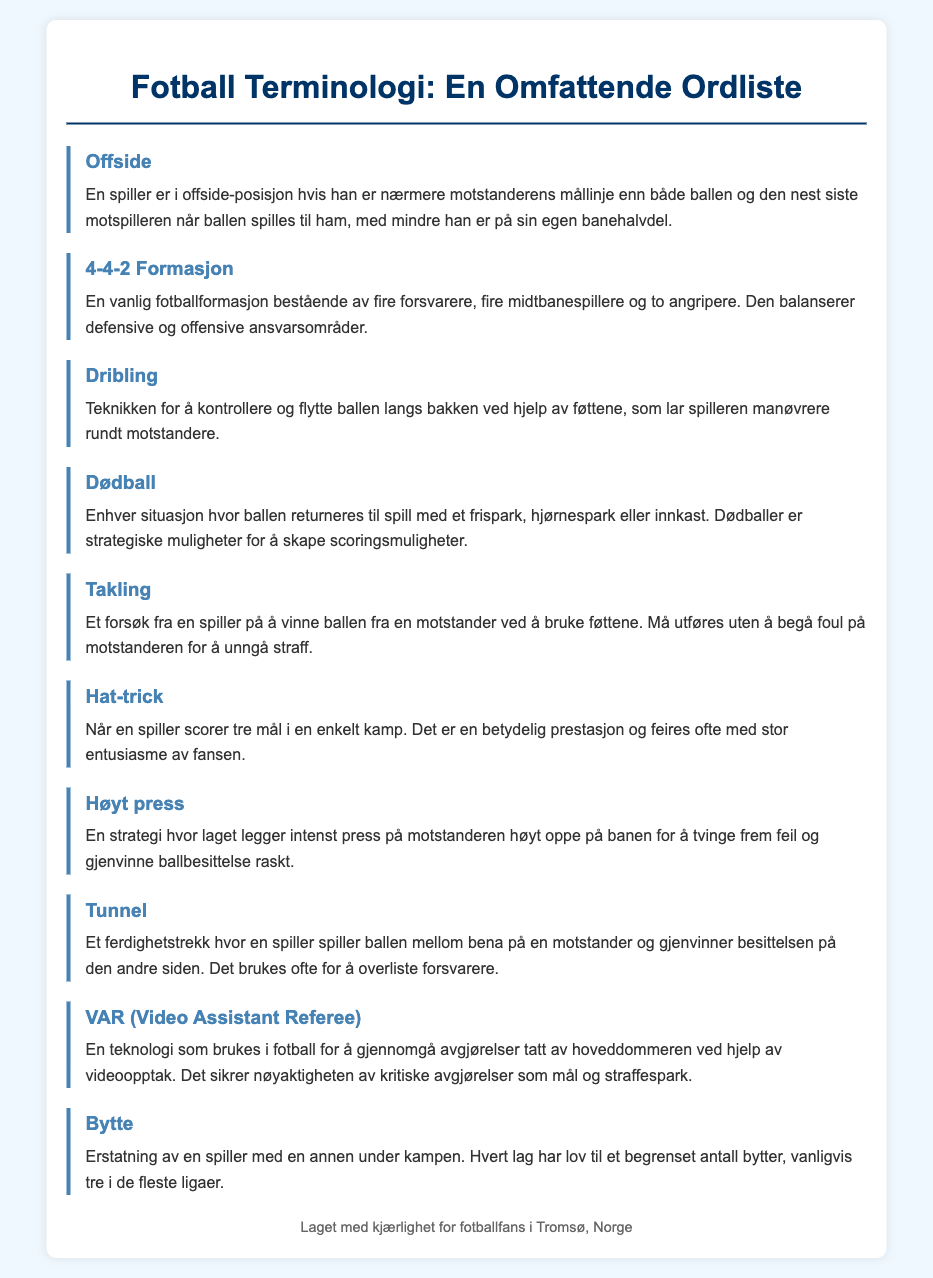What is the definition of offside? Offside is defined in the glossary as a position where a player is closer to the opponent's goal line than both the ball and the second last opponent when the ball is played to him, unless he is in his own half.
Answer: En spiller er i offside-posisjon hvis han er nærmere motstanderens mållinje enn både ballen og den nest siste motspilleren når ballen spilles til ham, med mindre han er på sin egen banehalvdel What does 4-4-2 formation consist of? The 4-4-2 formation consists of four defenders, four midfielders, and two forwards, balancing defensive and offensive responsibilities.
Answer: Fire forsvarere, fire midtbanespillere og to angripere What is a hat-trick? A hat-trick is when a player scores three goals in a single match, which is a significant achievement celebrated by fans.
Answer: Når en spiller scorer tre mål i en enkelt kamp What is the purpose of dead balls? Dead balls provide strategic opportunities to create scoring chances through free kicks, corner kicks, or throw-ins.
Answer: Strategiske muligheter for å skape scoringsmuligheter How many substitutions are typically allowed in most leagues? Most leagues typically allow three substitutes during a match.
Answer: Vanligvis tre What strategy does "high pressing" involve? High pressing involves putting intense pressure on the opponent high up the pitch to force errors and quickly regain possession.
Answer: Legge intenst press på motstanderen høyt oppe på banen What does VAR stand for? VAR stands for Video Assistant Referee, a technology used to review decisions made by the main referee.
Answer: Video Assistant Referee What skill does the term "tunnel" refer to? Tunnel refers to the skill of playing the ball between an opponent's legs and regaining possession on the other side.
Answer: Spille ballen mellom bena på en motstander What does a tackle attempt to do? A tackle is an attempt by a player to win the ball from an opponent using their feet.
Answer: Vinne ballen fra en motstander ved å bruke føttene 